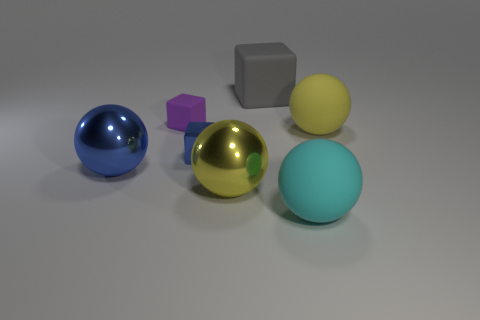Add 1 big metal blocks. How many objects exist? 8 Subtract all blocks. How many objects are left? 4 Add 1 large gray things. How many large gray things are left? 2 Add 4 matte cubes. How many matte cubes exist? 6 Subtract 1 blue blocks. How many objects are left? 6 Subtract all matte spheres. Subtract all big purple balls. How many objects are left? 5 